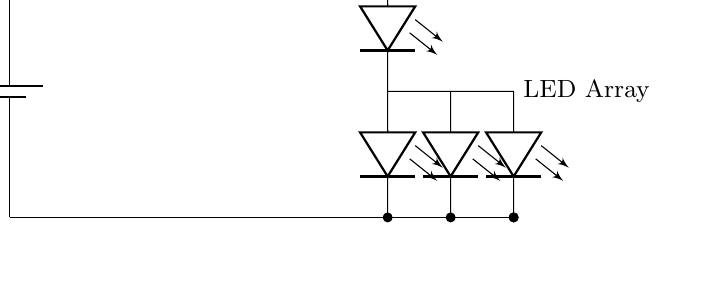What is the power source for this circuit? The circuit is powered by a USB source, as indicated by the label on the battery symbol.
Answer: USB What is the voltage supplied by the power source? The voltage labeled on the power source is 5 volts, which is indicated next to the USB symbol in the circuit.
Answer: 5 volts What component is used to switch the lamp on and off? The component responsible for switching the lamp on and off is the switch labeled SW in the circuit diagram.
Answer: Switch How many LEDs are connected in this circuit? There are a total of four LEDs connected in the circuit, as shown by the number of leDo symbols drawn.
Answer: Four What role does the resistor play in this circuit? The resistor, labeled as R_LED, is used to limit the current flowing through the LEDs to prevent them from drawing too much current and burning out.
Answer: Current limiter What connects the LED array to the ground in this circuit? The ground connection is established by a wire that connects from the base of the LED array to the ground level, ensuring it completes the circuit.
Answer: Ground connection What happens when the switch is in the off position? When the switch is in the off position, the circuit is open, preventing any current flow that would otherwise light up the LED array.
Answer: Circuit open 